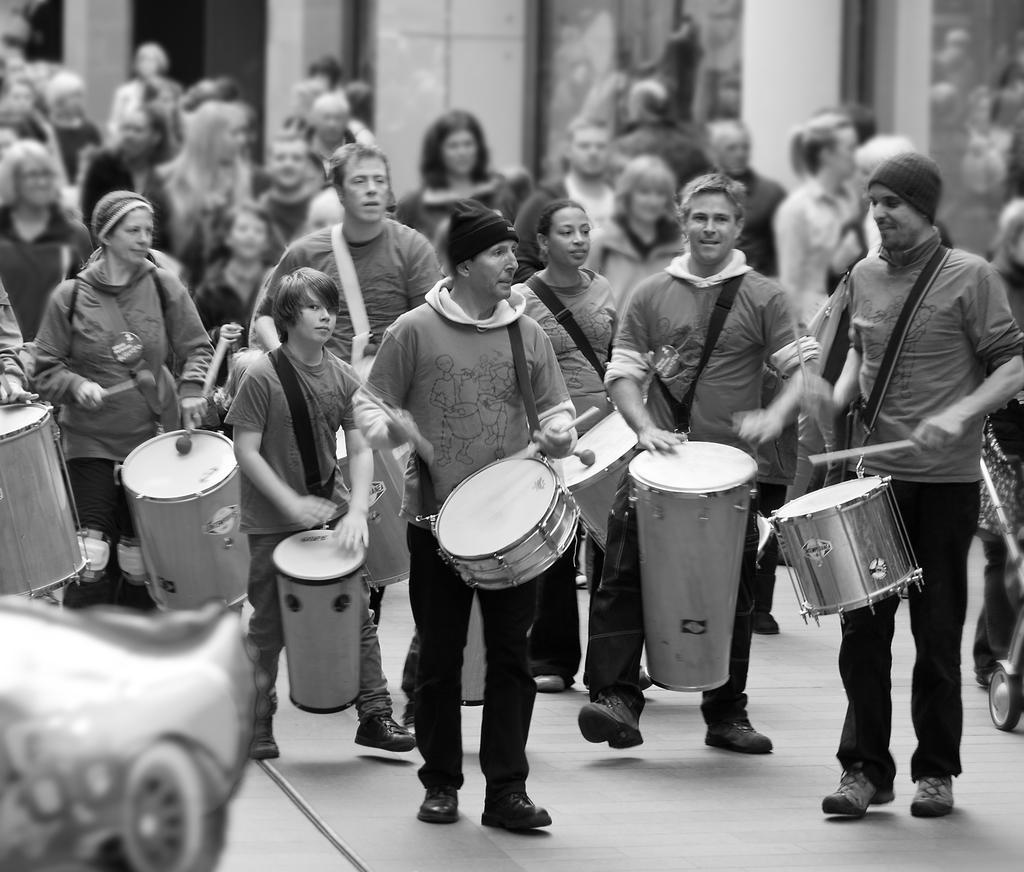How would you summarize this image in a sentence or two? In this picture we can see group of people, they are walking on the road and playing some musical instruments. 